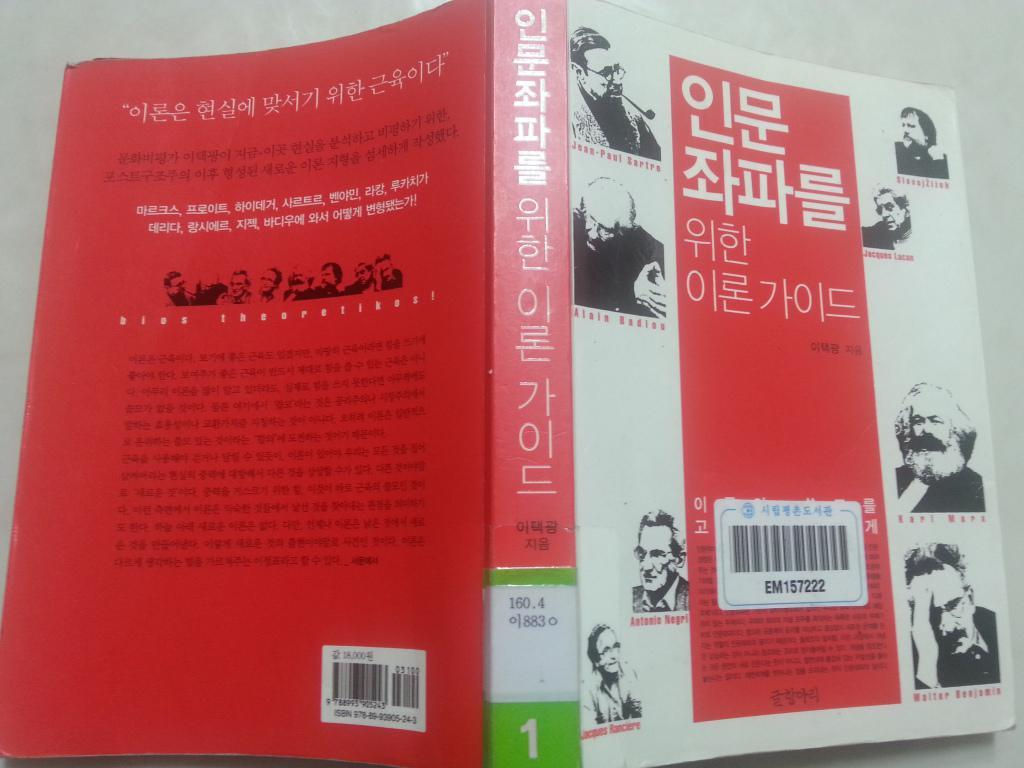<image>
Describe the image concisely. a red and white library book with chinese writing 